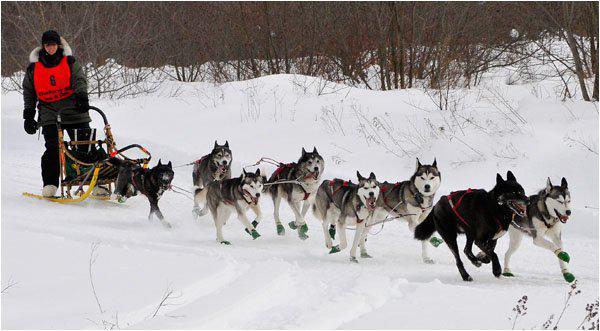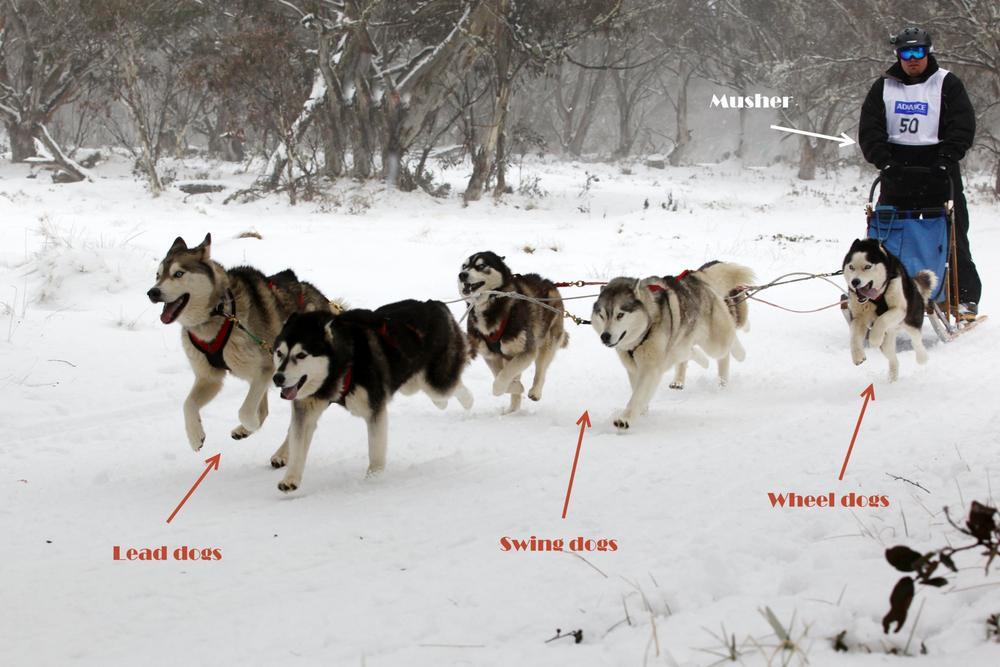The first image is the image on the left, the second image is the image on the right. Examine the images to the left and right. Is the description "In one image a team of sled dogs are pulling a person to the left." accurate? Answer yes or no. Yes. The first image is the image on the left, the second image is the image on the right. Evaluate the accuracy of this statement regarding the images: "At least one of the teams is exactly six dogs.". Is it true? Answer yes or no. Yes. 